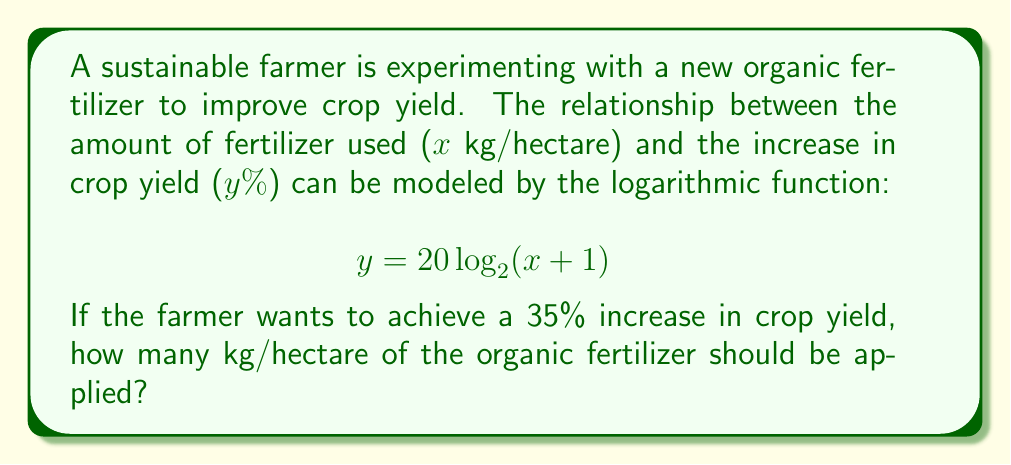Could you help me with this problem? To solve this problem, we need to use the given logarithmic function and solve for x when y = 35. Let's approach this step-by-step:

1) We start with the equation:
   $$ y = 20 \log_2(x + 1) $$

2) We want to find x when y = 35, so let's substitute:
   $$ 35 = 20 \log_2(x + 1) $$

3) Divide both sides by 20:
   $$ \frac{35}{20} = \log_2(x + 1) $$

4) Simplify:
   $$ 1.75 = \log_2(x + 1) $$

5) To solve for x, we need to apply the inverse function (exponential) to both sides:
   $$ 2^{1.75} = x + 1 $$

6) Calculate $2^{1.75}$:
   $$ 3.3636 \approx x + 1 $$

7) Subtract 1 from both sides:
   $$ 2.3636 \approx x $$

8) Round to two decimal places:
   $$ x \approx 2.36 $$

Therefore, the farmer should apply approximately 2.36 kg/hectare of the organic fertilizer to achieve a 35% increase in crop yield.
Answer: 2.36 kg/hectare 